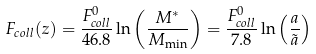Convert formula to latex. <formula><loc_0><loc_0><loc_500><loc_500>F _ { c o l l } ( z ) = \frac { F ^ { 0 } _ { c o l l } } { 4 6 . 8 } \ln \left ( \frac { M ^ { * } } { M _ { \min } } \right ) = \frac { F ^ { 0 } _ { c o l l } } { 7 . 8 } \ln \left ( \frac { a } { \tilde { a } } \right )</formula> 